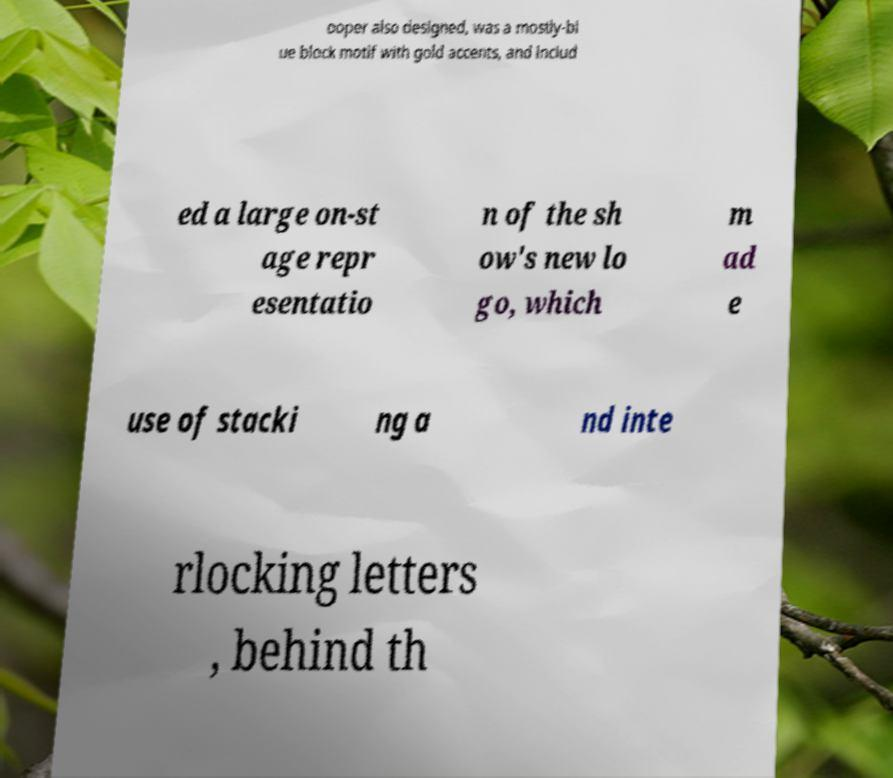There's text embedded in this image that I need extracted. Can you transcribe it verbatim? ooper also designed, was a mostly-bl ue block motif with gold accents, and includ ed a large on-st age repr esentatio n of the sh ow's new lo go, which m ad e use of stacki ng a nd inte rlocking letters , behind th 